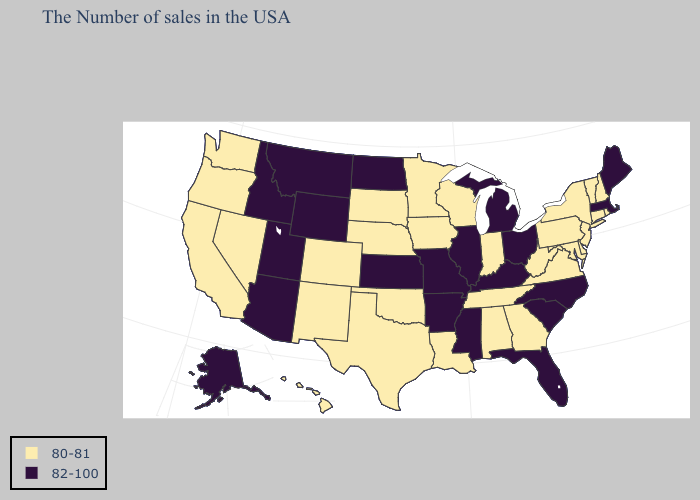Does the first symbol in the legend represent the smallest category?
Write a very short answer. Yes. What is the value of Mississippi?
Be succinct. 82-100. Name the states that have a value in the range 82-100?
Short answer required. Maine, Massachusetts, North Carolina, South Carolina, Ohio, Florida, Michigan, Kentucky, Illinois, Mississippi, Missouri, Arkansas, Kansas, North Dakota, Wyoming, Utah, Montana, Arizona, Idaho, Alaska. Name the states that have a value in the range 80-81?
Keep it brief. Rhode Island, New Hampshire, Vermont, Connecticut, New York, New Jersey, Delaware, Maryland, Pennsylvania, Virginia, West Virginia, Georgia, Indiana, Alabama, Tennessee, Wisconsin, Louisiana, Minnesota, Iowa, Nebraska, Oklahoma, Texas, South Dakota, Colorado, New Mexico, Nevada, California, Washington, Oregon, Hawaii. What is the lowest value in states that border New Mexico?
Quick response, please. 80-81. Which states have the lowest value in the MidWest?
Short answer required. Indiana, Wisconsin, Minnesota, Iowa, Nebraska, South Dakota. Does Washington have a lower value than Illinois?
Write a very short answer. Yes. Does Massachusetts have the highest value in the Northeast?
Concise answer only. Yes. Name the states that have a value in the range 82-100?
Write a very short answer. Maine, Massachusetts, North Carolina, South Carolina, Ohio, Florida, Michigan, Kentucky, Illinois, Mississippi, Missouri, Arkansas, Kansas, North Dakota, Wyoming, Utah, Montana, Arizona, Idaho, Alaska. What is the value of California?
Keep it brief. 80-81. Name the states that have a value in the range 82-100?
Be succinct. Maine, Massachusetts, North Carolina, South Carolina, Ohio, Florida, Michigan, Kentucky, Illinois, Mississippi, Missouri, Arkansas, Kansas, North Dakota, Wyoming, Utah, Montana, Arizona, Idaho, Alaska. Name the states that have a value in the range 82-100?
Write a very short answer. Maine, Massachusetts, North Carolina, South Carolina, Ohio, Florida, Michigan, Kentucky, Illinois, Mississippi, Missouri, Arkansas, Kansas, North Dakota, Wyoming, Utah, Montana, Arizona, Idaho, Alaska. Name the states that have a value in the range 82-100?
Quick response, please. Maine, Massachusetts, North Carolina, South Carolina, Ohio, Florida, Michigan, Kentucky, Illinois, Mississippi, Missouri, Arkansas, Kansas, North Dakota, Wyoming, Utah, Montana, Arizona, Idaho, Alaska. What is the value of West Virginia?
Quick response, please. 80-81. 